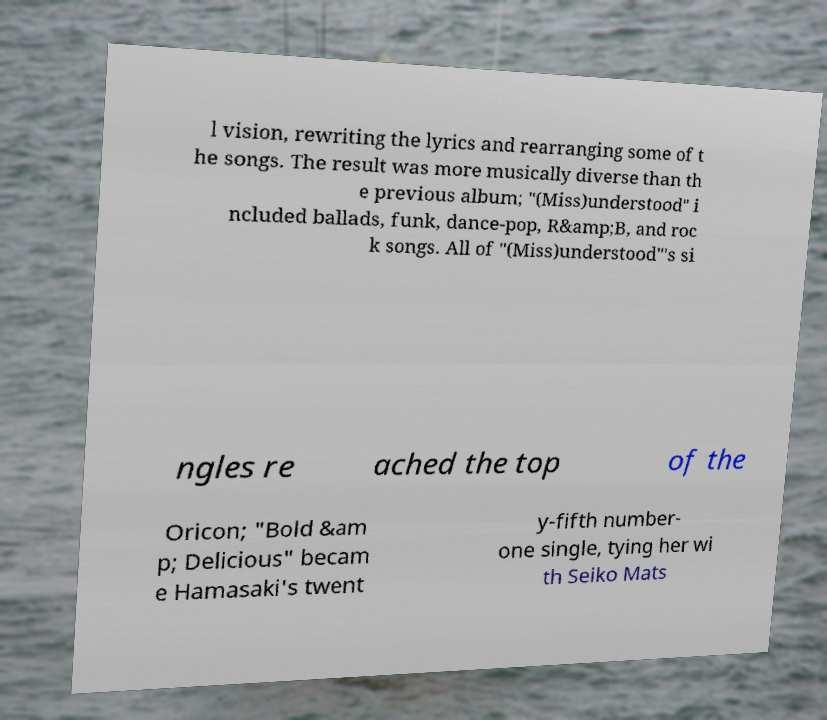There's text embedded in this image that I need extracted. Can you transcribe it verbatim? l vision, rewriting the lyrics and rearranging some of t he songs. The result was more musically diverse than th e previous album; "(Miss)understood" i ncluded ballads, funk, dance-pop, R&amp;B, and roc k songs. All of "(Miss)understood"'s si ngles re ached the top of the Oricon; "Bold &am p; Delicious" becam e Hamasaki's twent y-fifth number- one single, tying her wi th Seiko Mats 